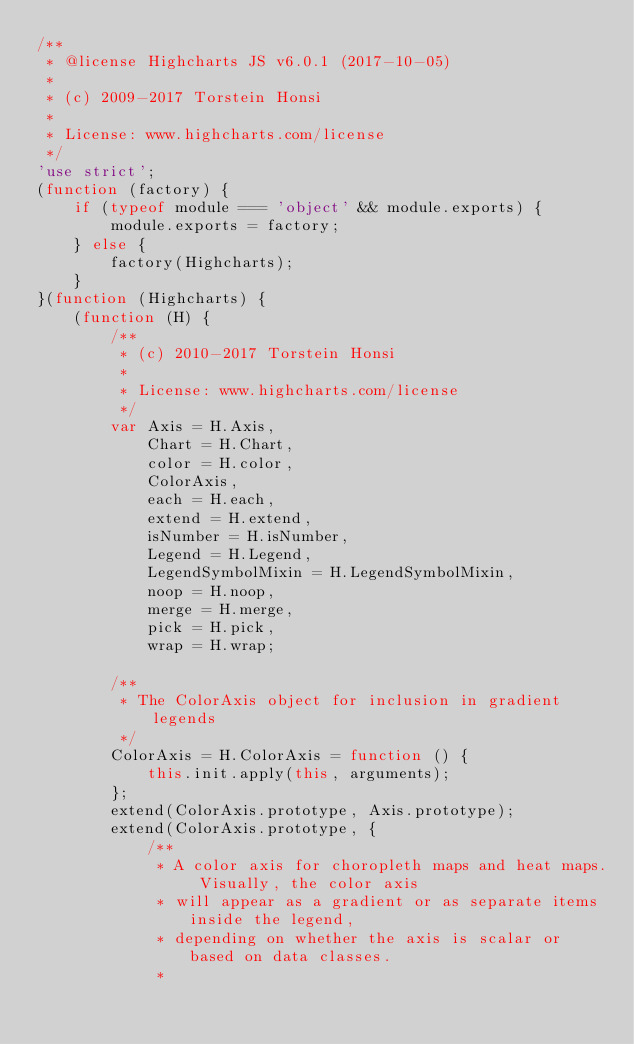Convert code to text. <code><loc_0><loc_0><loc_500><loc_500><_JavaScript_>/**
 * @license Highcharts JS v6.0.1 (2017-10-05)
 *
 * (c) 2009-2017 Torstein Honsi
 *
 * License: www.highcharts.com/license
 */
'use strict';
(function (factory) {
    if (typeof module === 'object' && module.exports) {
        module.exports = factory;
    } else {
        factory(Highcharts);
    }
}(function (Highcharts) {
    (function (H) {
        /**
         * (c) 2010-2017 Torstein Honsi
         *
         * License: www.highcharts.com/license
         */
        var Axis = H.Axis,
            Chart = H.Chart,
            color = H.color,
            ColorAxis,
            each = H.each,
            extend = H.extend,
            isNumber = H.isNumber,
            Legend = H.Legend,
            LegendSymbolMixin = H.LegendSymbolMixin,
            noop = H.noop,
            merge = H.merge,
            pick = H.pick,
            wrap = H.wrap;

        /**
         * The ColorAxis object for inclusion in gradient legends
         */
        ColorAxis = H.ColorAxis = function () {
            this.init.apply(this, arguments);
        };
        extend(ColorAxis.prototype, Axis.prototype);
        extend(ColorAxis.prototype, {
            /**
             * A color axis for choropleth maps and heat maps. Visually, the color axis
             * will appear as a gradient or as separate items inside the legend,
             * depending on whether the axis is scalar or based on data classes.
             *</code> 